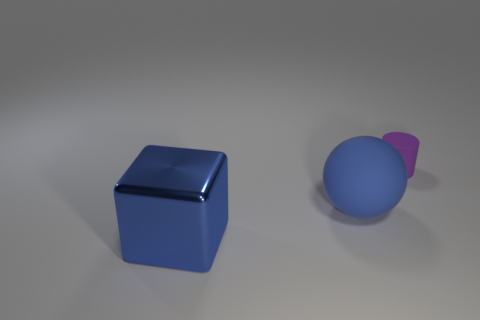Is there anything else that is the same material as the big blue cube?
Provide a short and direct response. No. Are there fewer blue balls than tiny purple metal objects?
Your answer should be compact. No. There is a matte object behind the rubber thing that is in front of the matte cylinder; how many rubber spheres are behind it?
Provide a succinct answer. 0. There is a blue object that is to the right of the block; how big is it?
Ensure brevity in your answer.  Large. Does the blue thing right of the metal object have the same shape as the metallic object?
Provide a short and direct response. No. Is there any other thing that is the same size as the purple object?
Provide a short and direct response. No. Are any tiny gray rubber objects visible?
Your response must be concise. No. What is the big blue object that is right of the blue object on the left side of the rubber object that is in front of the purple thing made of?
Your answer should be very brief. Rubber. Is the shape of the small purple object the same as the big object that is to the right of the metallic thing?
Give a very brief answer. No. There is a shiny object; what shape is it?
Offer a very short reply. Cube. 